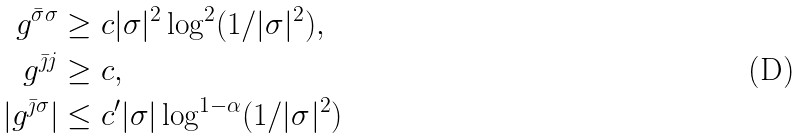Convert formula to latex. <formula><loc_0><loc_0><loc_500><loc_500>g ^ { \bar { \sigma } \sigma } & \geq c | \sigma | ^ { 2 } \log ^ { 2 } ( 1 / | \sigma | ^ { 2 } ) , \\ g ^ { \bar { \jmath } j } & \geq c , \\ | g ^ { \bar { \jmath } \sigma } | & \leq c ^ { \prime } | \sigma | \log ^ { 1 - \alpha } ( 1 / | \sigma | ^ { 2 } )</formula> 